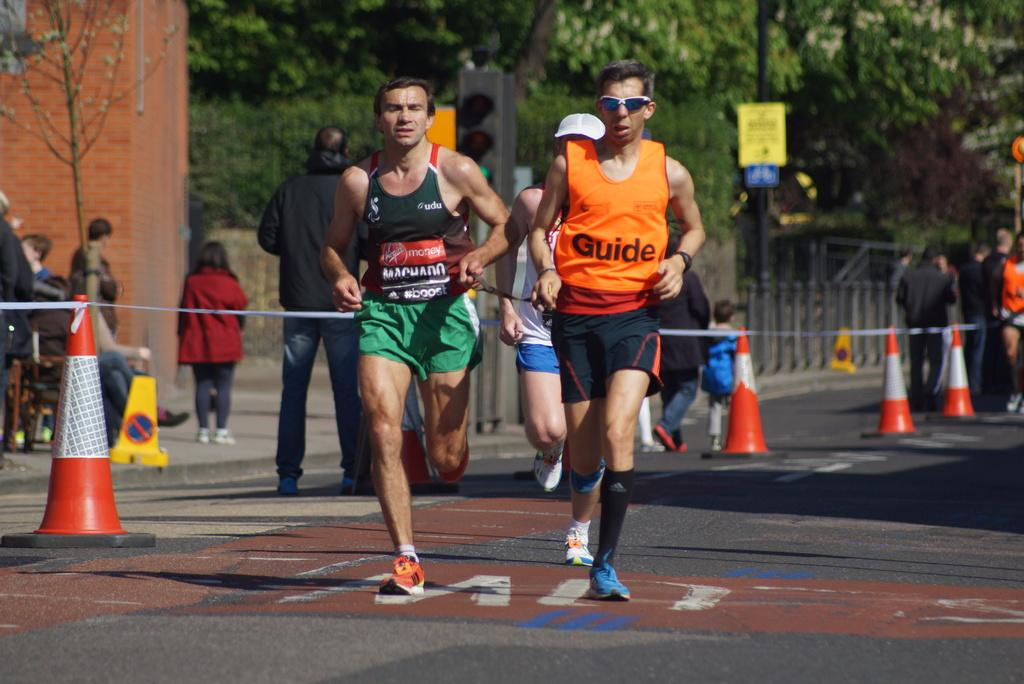<image>
Present a compact description of the photo's key features. Two men are running, one is wearing a bright orange Guide shirt. 